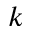<formula> <loc_0><loc_0><loc_500><loc_500>k</formula> 